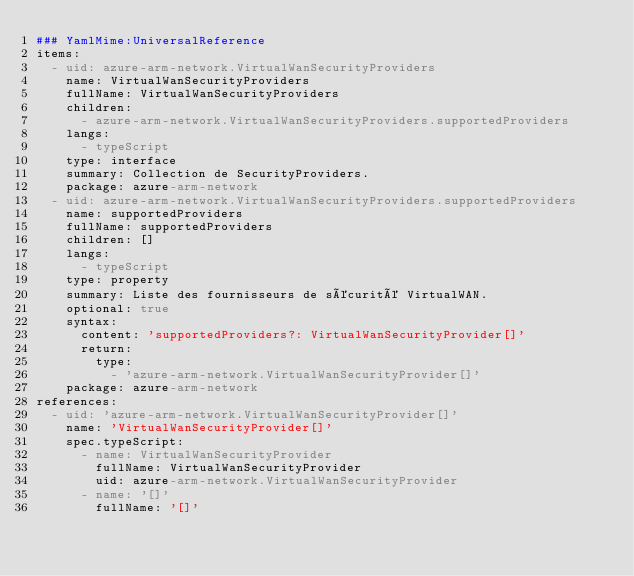<code> <loc_0><loc_0><loc_500><loc_500><_YAML_>### YamlMime:UniversalReference
items:
  - uid: azure-arm-network.VirtualWanSecurityProviders
    name: VirtualWanSecurityProviders
    fullName: VirtualWanSecurityProviders
    children:
      - azure-arm-network.VirtualWanSecurityProviders.supportedProviders
    langs:
      - typeScript
    type: interface
    summary: Collection de SecurityProviders.
    package: azure-arm-network
  - uid: azure-arm-network.VirtualWanSecurityProviders.supportedProviders
    name: supportedProviders
    fullName: supportedProviders
    children: []
    langs:
      - typeScript
    type: property
    summary: Liste des fournisseurs de sécurité VirtualWAN.
    optional: true
    syntax:
      content: 'supportedProviders?: VirtualWanSecurityProvider[]'
      return:
        type:
          - 'azure-arm-network.VirtualWanSecurityProvider[]'
    package: azure-arm-network
references:
  - uid: 'azure-arm-network.VirtualWanSecurityProvider[]'
    name: 'VirtualWanSecurityProvider[]'
    spec.typeScript:
      - name: VirtualWanSecurityProvider
        fullName: VirtualWanSecurityProvider
        uid: azure-arm-network.VirtualWanSecurityProvider
      - name: '[]'
        fullName: '[]'</code> 